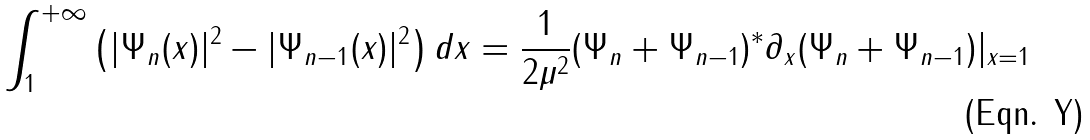Convert formula to latex. <formula><loc_0><loc_0><loc_500><loc_500>\int _ { 1 } ^ { + \infty } \left ( | \Psi _ { n } ( x ) | ^ { 2 } - | \Psi _ { n - 1 } ( x ) | ^ { 2 } \right ) d x = \frac { 1 } { 2 \mu ^ { 2 } } ( \Psi _ { n } + \Psi _ { n - 1 } ) ^ { * } \partial _ { x } ( \Psi _ { n } + \Psi _ { n - 1 } ) | _ { x = 1 }</formula> 